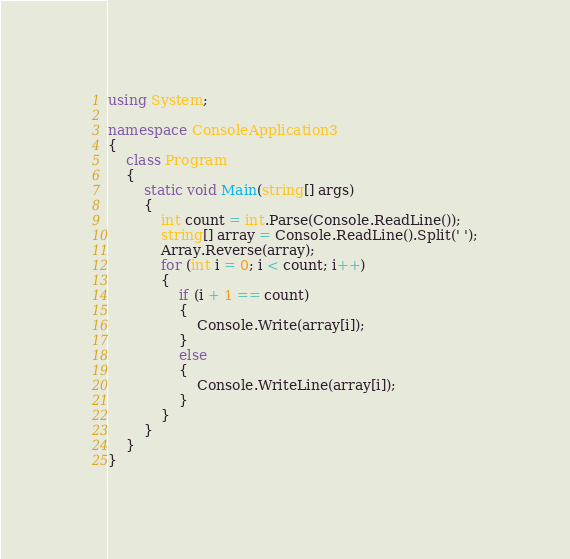Convert code to text. <code><loc_0><loc_0><loc_500><loc_500><_C#_>using System;

namespace ConsoleApplication3
{
    class Program
    {
        static void Main(string[] args)
        {
            int count = int.Parse(Console.ReadLine());
            string[] array = Console.ReadLine().Split(' ');
            Array.Reverse(array);
            for (int i = 0; i < count; i++)
            {
                if (i + 1 == count)
                {
                    Console.Write(array[i]);
                }
                else
                {
                    Console.WriteLine(array[i]);
                }
            }
        }
    }
}</code> 